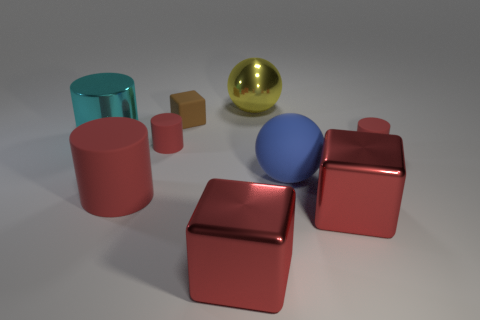Subtract all red blocks. How many red cylinders are left? 3 Subtract 1 cylinders. How many cylinders are left? 3 Subtract all spheres. How many objects are left? 7 Subtract all big matte cylinders. Subtract all large blue objects. How many objects are left? 7 Add 7 blue things. How many blue things are left? 8 Add 6 balls. How many balls exist? 8 Subtract 0 cyan spheres. How many objects are left? 9 